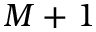<formula> <loc_0><loc_0><loc_500><loc_500>M + 1</formula> 